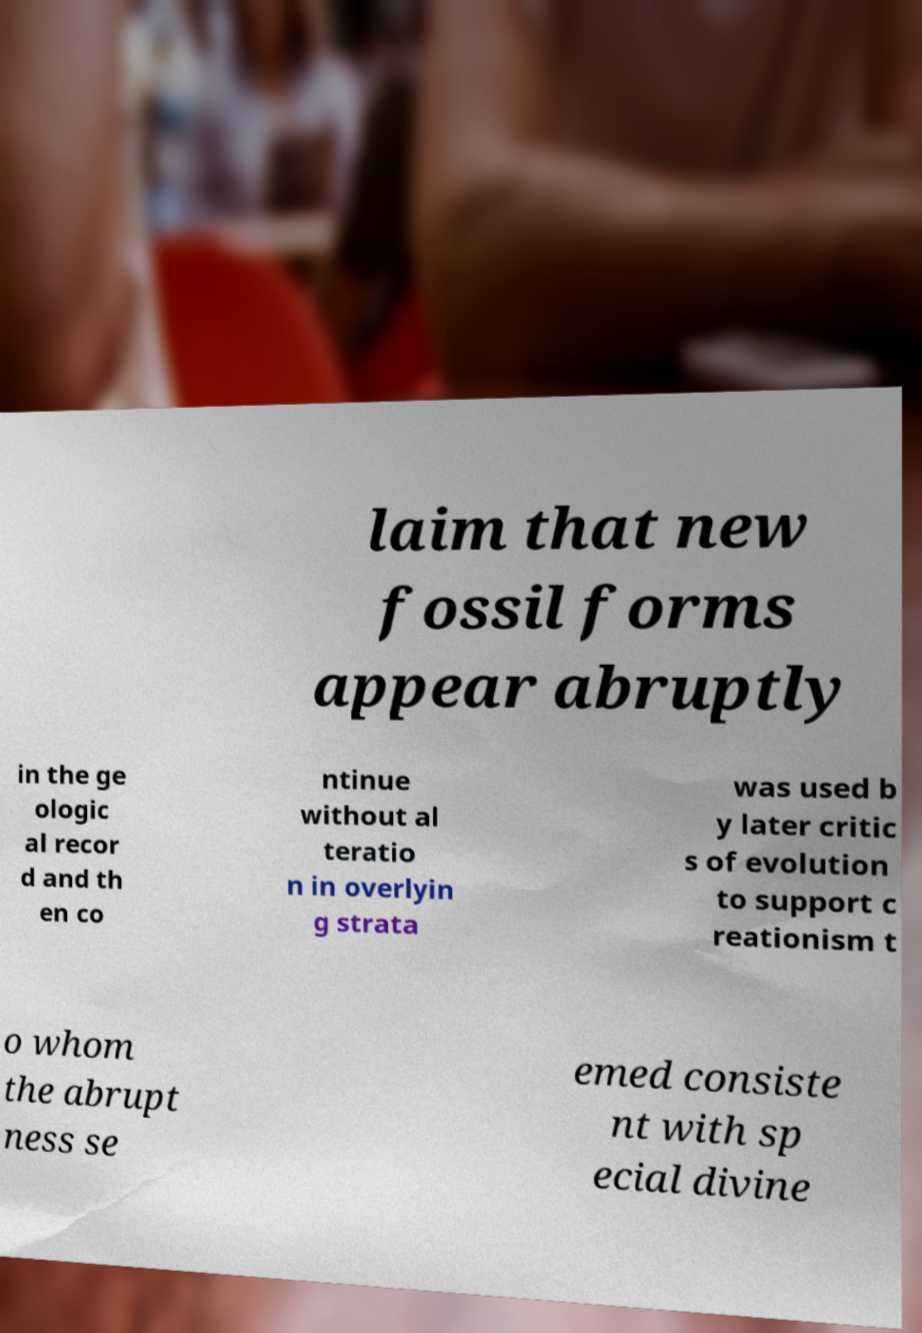For documentation purposes, I need the text within this image transcribed. Could you provide that? laim that new fossil forms appear abruptly in the ge ologic al recor d and th en co ntinue without al teratio n in overlyin g strata was used b y later critic s of evolution to support c reationism t o whom the abrupt ness se emed consiste nt with sp ecial divine 